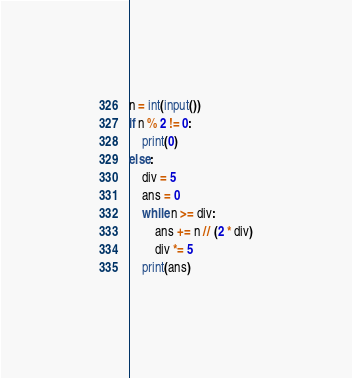Convert code to text. <code><loc_0><loc_0><loc_500><loc_500><_Python_>n = int(input())
if n % 2 != 0:
    print(0)
else:
    div = 5
    ans = 0
    while n >= div:
        ans += n // (2 * div)
        div *= 5
    print(ans)</code> 